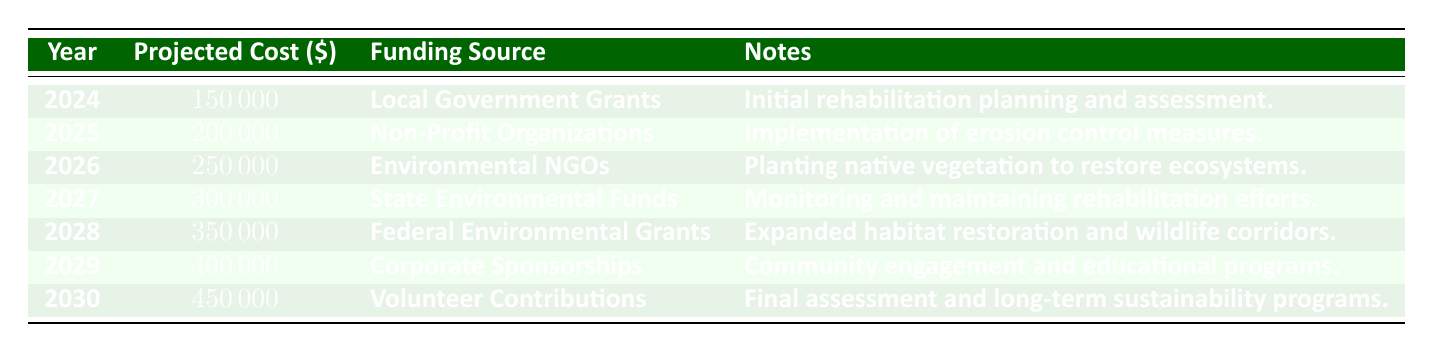What is the projected cost for land rehabilitation in 2025? The table shows that for the year 2025, the projected cost is listed under the "Projected Cost" column. Specifically, it states that the projected cost is 200000.
Answer: 200000 Which funding source is allocated for the year 2028? By examining the "Funding Source" column for the year 2028, I can see that it is "Federal Environmental Grants."
Answer: Federal Environmental Grants What will be the total projected cost for the years 2026 and 2027 combined? To find the total cost for 2026 and 2027: the projected cost for 2026 is 250000 and for 2027 is 300000. Adding these together gives 250000 + 300000 = 550000.
Answer: 550000 Is the projected cost higher in 2030 than in 2024? In the table, the projected cost for 2030 is 450000 and for 2024 it is 150000. Since 450000 is greater than 150000, the answer is yes.
Answer: Yes What is the average projected cost over the 7 years from 2024 to 2030? To find the average, I need to sum the projected costs for each year: 150000 + 200000 + 250000 + 300000 + 350000 + 400000 + 450000 = 2100000. There are 7 years, so dividing the total by 7 gives 2100000 / 7 = 300000.
Answer: 300000 How much more funding is expected from corporate sponsorships in 2029 compared to environmental NGOs in 2026? In the table, the projected cost for corporate sponsorships in 2029 is 400000 and for environmental NGOs in 2026 it is 250000. The difference is 400000 - 250000 = 150000.
Answer: 150000 Will the projected costs continue to increase every year? By checking the "Projected Cost" column year by year, I can see that each year from 2024 to 2030 shows an increase. Hence, the answer is yes.
Answer: Yes 